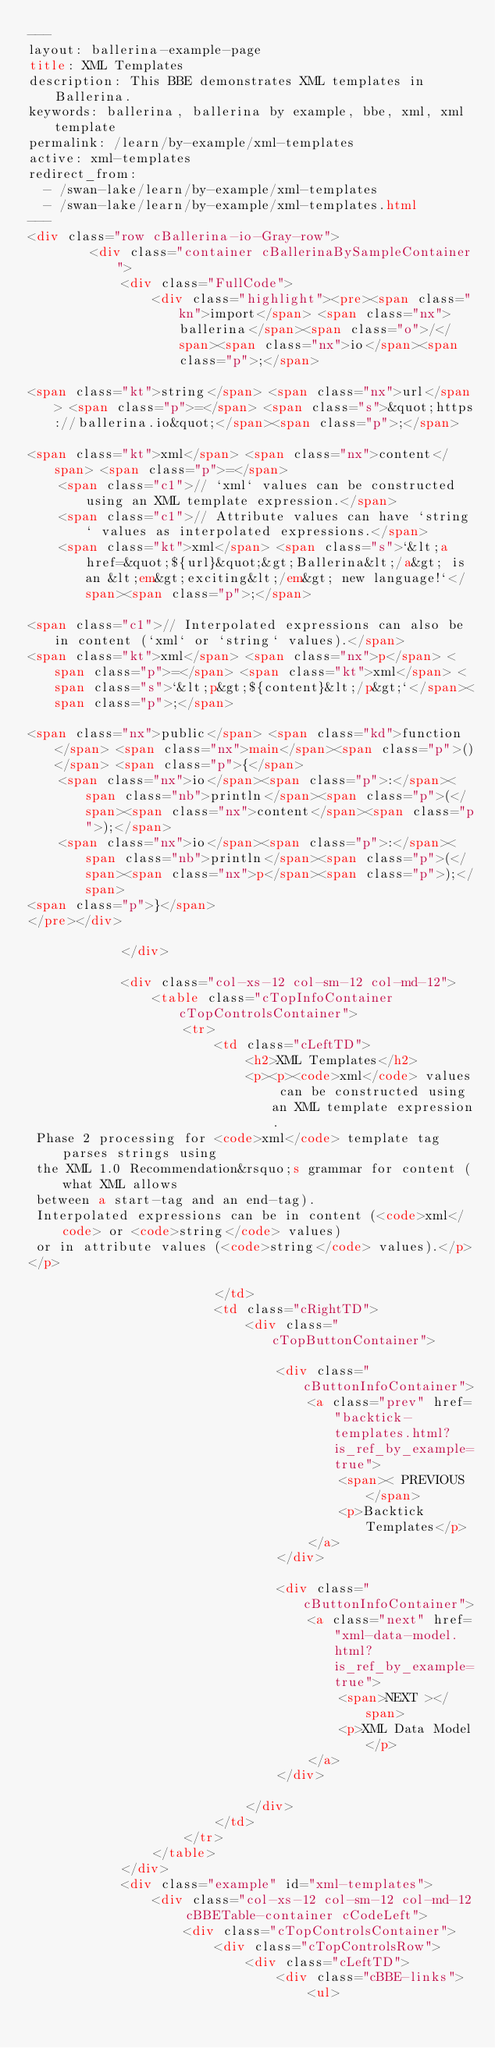<code> <loc_0><loc_0><loc_500><loc_500><_HTML_>---
layout: ballerina-example-page
title: XML Templates
description: This BBE demonstrates XML templates in Ballerina.
keywords: ballerina, ballerina by example, bbe, xml, xml template
permalink: /learn/by-example/xml-templates
active: xml-templates
redirect_from:
  - /swan-lake/learn/by-example/xml-templates
  - /swan-lake/learn/by-example/xml-templates.html
---
<div class="row cBallerina-io-Gray-row">
        <div class="container cBallerinaBySampleContainer">
            <div class="FullCode">
                <div class="highlight"><pre><span class="kn">import</span> <span class="nx">ballerina</span><span class="o">/</span><span class="nx">io</span><span class="p">;</span>

<span class="kt">string</span> <span class="nx">url</span> <span class="p">=</span> <span class="s">&quot;https://ballerina.io&quot;</span><span class="p">;</span>

<span class="kt">xml</span> <span class="nx">content</span> <span class="p">=</span> 
    <span class="c1">// `xml` values can be constructed using an XML template expression.</span>
    <span class="c1">// Attribute values can have `string` values as interpolated expressions.</span>
    <span class="kt">xml</span> <span class="s">`&lt;a href=&quot;${url}&quot;&gt;Ballerina&lt;/a&gt; is an &lt;em&gt;exciting&lt;/em&gt; new language!`</span><span class="p">;</span>

<span class="c1">// Interpolated expressions can also be in content (`xml` or `string` values).</span>
<span class="kt">xml</span> <span class="nx">p</span> <span class="p">=</span> <span class="kt">xml</span> <span class="s">`&lt;p&gt;${content}&lt;/p&gt;`</span><span class="p">;</span>

<span class="nx">public</span> <span class="kd">function</span> <span class="nx">main</span><span class="p">()</span> <span class="p">{</span>
    <span class="nx">io</span><span class="p">:</span><span class="nb">println</span><span class="p">(</span><span class="nx">content</span><span class="p">);</span>
    <span class="nx">io</span><span class="p">:</span><span class="nb">println</span><span class="p">(</span><span class="nx">p</span><span class="p">);</span>
<span class="p">}</span>
</pre></div>

            </div>

            <div class="col-xs-12 col-sm-12 col-md-12">
                <table class="cTopInfoContainer cTopControlsContainer">
                    <tr>
                        <td class="cLeftTD">
                            <h2>XML Templates</h2>
                            <p><p><code>xml</code> values can be constructed using an XML template expression.
 Phase 2 processing for <code>xml</code> template tag parses strings using
 the XML 1.0 Recommendation&rsquo;s grammar for content (what XML allows
 between a start-tag and an end-tag).
 Interpolated expressions can be in content (<code>xml</code> or <code>string</code> values)
 or in attribute values (<code>string</code> values).</p>
</p>

                        </td>
                        <td class="cRightTD">
                            <div class="cTopButtonContainer">
                                
                                <div class="cButtonInfoContainer">
                                    <a class="prev" href="backtick-templates.html?is_ref_by_example=true">
                                        <span>< PREVIOUS</span>
                                        <p>Backtick Templates</p>
                                    </a>
                                </div>
                                 
                                <div class="cButtonInfoContainer">
                                    <a class="next" href="xml-data-model.html?is_ref_by_example=true">
                                        <span>NEXT ></span>
                                        <p>XML Data Model</p>
                                    </a>
                                </div>
                                
                            </div>
                        </td>
                    </tr>
                </table>
            </div>
            <div class="example" id="xml-templates">
                <div class="col-xs-12 col-sm-12 col-md-12 cBBETable-container cCodeLeft">
                    <div class="cTopControlsContainer">
                        <div class="cTopControlsRow">
                            <div class="cLeftTD">
                                <div class="cBBE-links">
                                    <ul></code> 